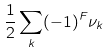<formula> <loc_0><loc_0><loc_500><loc_500>\frac { 1 } { 2 } \sum _ { k } ( - 1 ) ^ { F } \nu _ { k }</formula> 